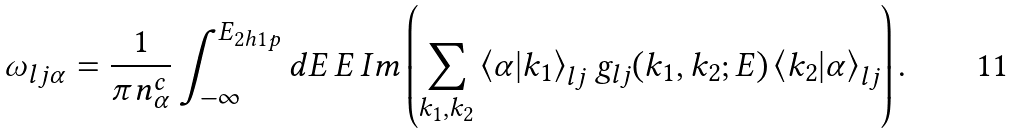<formula> <loc_0><loc_0><loc_500><loc_500>\omega _ { l j \alpha } = \frac { 1 } { \pi n ^ { c } _ { \alpha } } \int _ { - \infty } ^ { E _ { 2 h 1 p } } d E \, E \, I m \left ( \sum _ { k _ { 1 } , k _ { 2 } } \left \langle \alpha | k _ { 1 } \right \rangle _ { l j } g _ { l j } ( k _ { 1 } , k _ { 2 } ; E ) \left \langle k _ { 2 } | \alpha \right \rangle _ { l j } \right ) .</formula> 